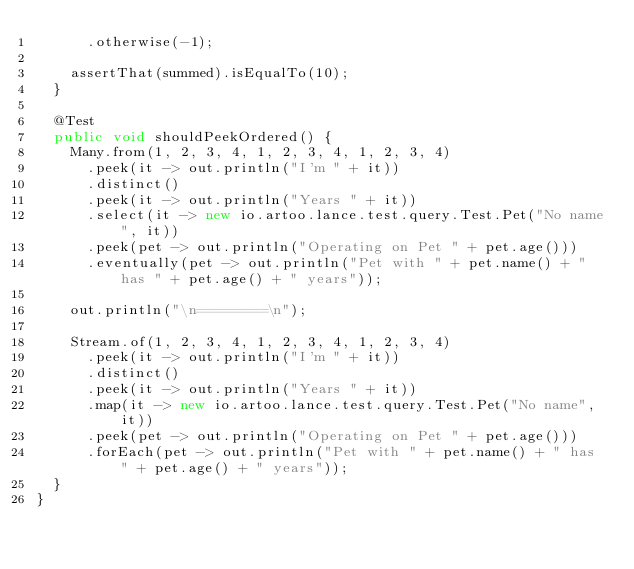<code> <loc_0><loc_0><loc_500><loc_500><_Java_>      .otherwise(-1);

    assertThat(summed).isEqualTo(10);
  }

  @Test
  public void shouldPeekOrdered() {
    Many.from(1, 2, 3, 4, 1, 2, 3, 4, 1, 2, 3, 4)
      .peek(it -> out.println("I'm " + it))
      .distinct()
      .peek(it -> out.println("Years " + it))
      .select(it -> new io.artoo.lance.test.query.Test.Pet("No name", it))
      .peek(pet -> out.println("Operating on Pet " + pet.age()))
      .eventually(pet -> out.println("Pet with " + pet.name() + " has " + pet.age() + " years"));

    out.println("\n========\n");

    Stream.of(1, 2, 3, 4, 1, 2, 3, 4, 1, 2, 3, 4)
      .peek(it -> out.println("I'm " + it))
      .distinct()
      .peek(it -> out.println("Years " + it))
      .map(it -> new io.artoo.lance.test.query.Test.Pet("No name", it))
      .peek(pet -> out.println("Operating on Pet " + pet.age()))
      .forEach(pet -> out.println("Pet with " + pet.name() + " has " + pet.age() + " years"));
  }
}
</code> 